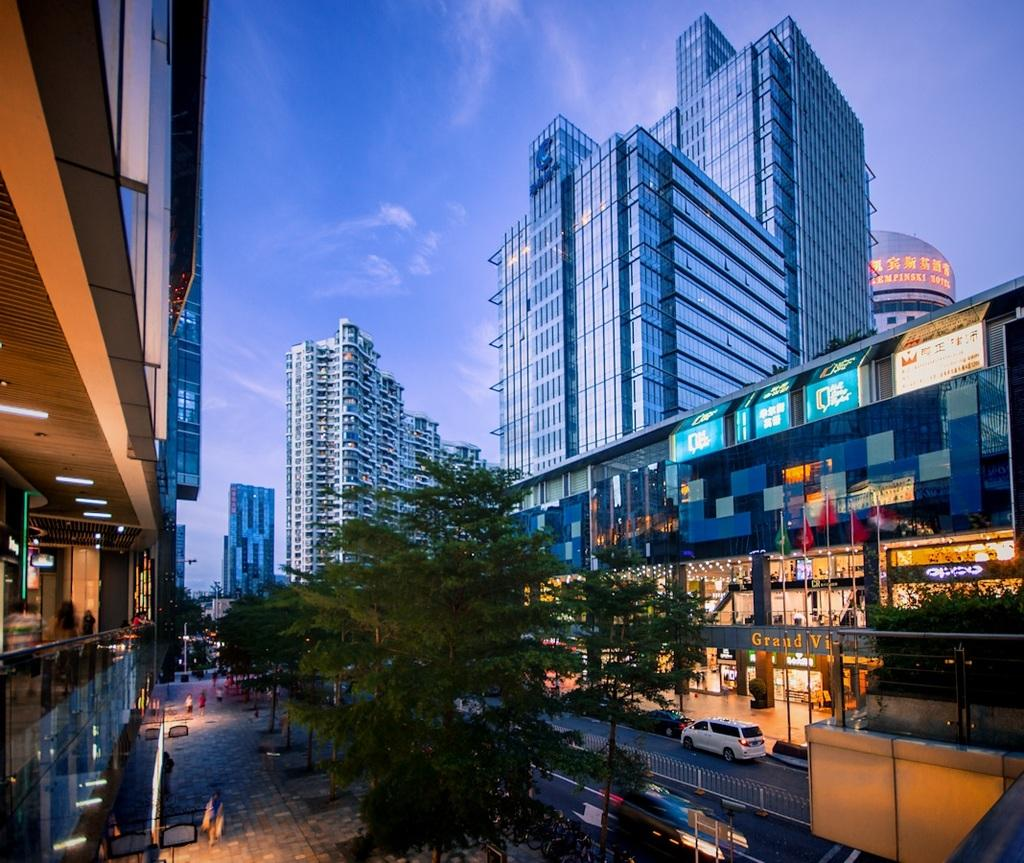What type of natural elements can be seen in the image? There are trees in the image. Can you describe the people in the image? There are people in the image. What is present on the road in the image? Vehicles are present on the road in the image. What type of barrier is visible in the image? There is a fence in the image. What structure is present in the image, elevated from the ground? There is a board on poles in the image. What type of man-made structures can be seen in the image? There are buildings in the image. What type of illumination is visible in the image? Lights are visible in the image. What can be seen in the background of the image? The sky is visible in the background of the image. What type of spoon is being used to polish the ducks in the image? There are no ducks or spoons present in the image, and therefore no such activity can be observed. 